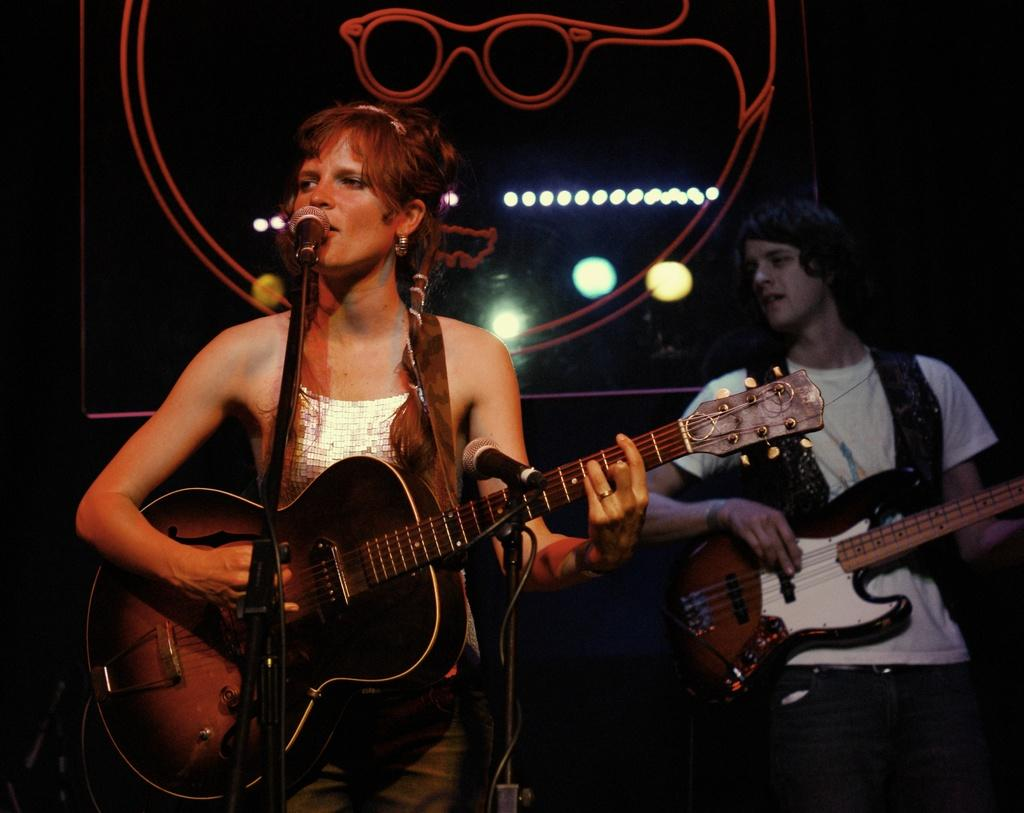What are the musicians doing in the image? The musicians are performing in the image. What can be seen in the front of the image? There is a microphone in the front of the image. What are the musicians using to create music? The musicians are playing musical instruments. What can be seen in the background of the image? There are lights in the background of the image. How many clocks are visible in the image? There are no clocks visible in the image. What type of machine is being used by the musicians in the image? There is no machine being used by the musicians in the image; they are playing musical instruments. 